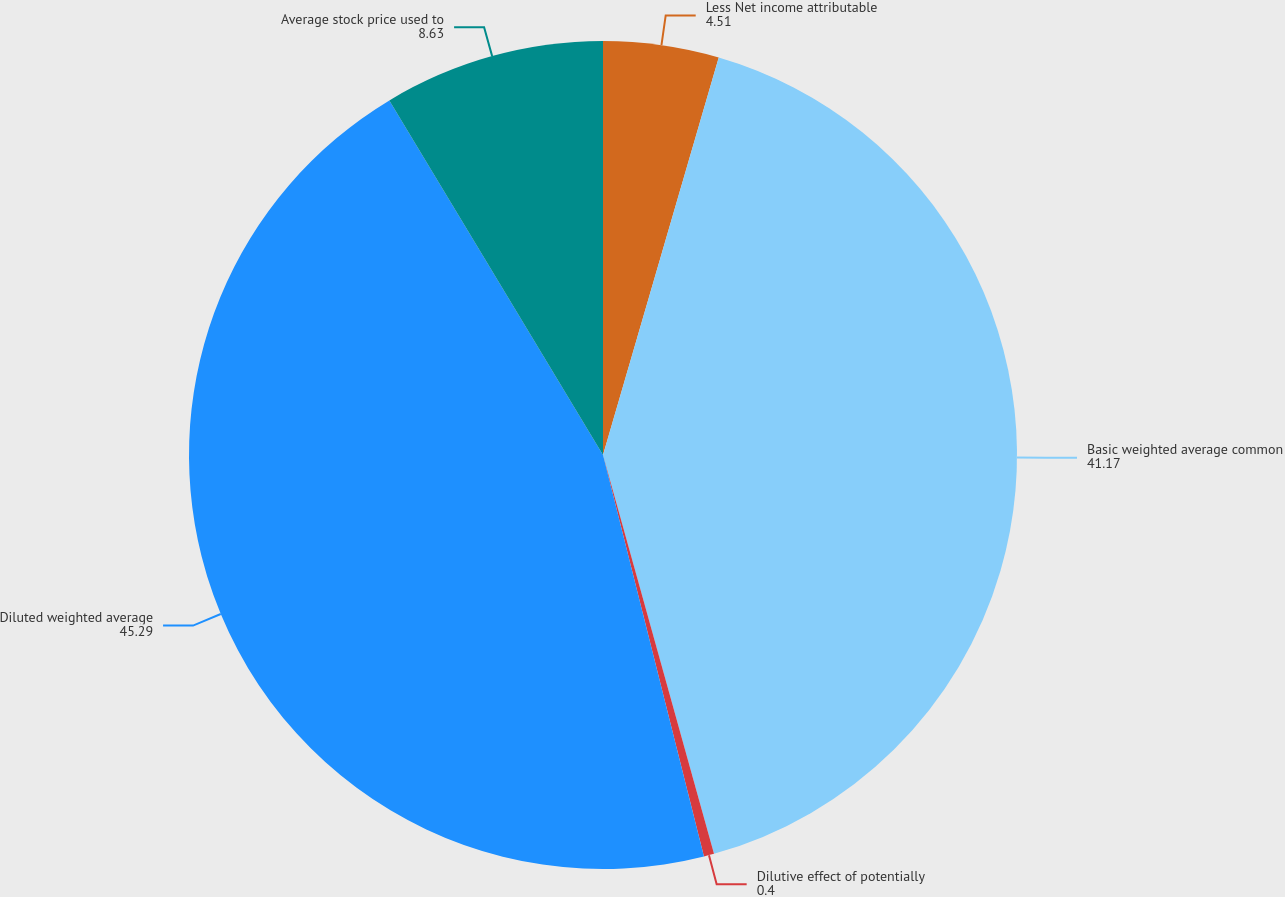Convert chart. <chart><loc_0><loc_0><loc_500><loc_500><pie_chart><fcel>Less Net income attributable<fcel>Basic weighted average common<fcel>Dilutive effect of potentially<fcel>Diluted weighted average<fcel>Average stock price used to<nl><fcel>4.51%<fcel>41.17%<fcel>0.4%<fcel>45.29%<fcel>8.63%<nl></chart> 